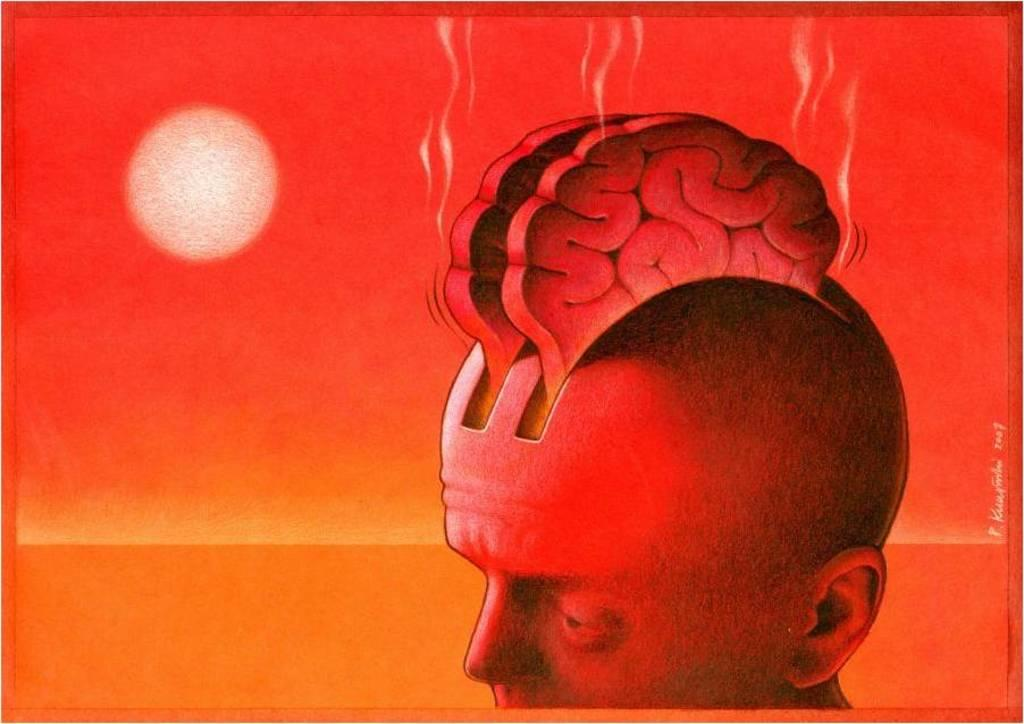What type of picture is in the image? The image contains an edited picture. What is the main subject of the edited picture? There is a human head in the edited picture. What colors are used for the background of the edited picture? The background of the edited picture is red and yellow colored. What celestial body can be seen in the background of the edited picture? The moon is visible in the background of the edited picture. What type of bell can be heard ringing in the image? There is no bell present in the image, and therefore no sound can be heard. 